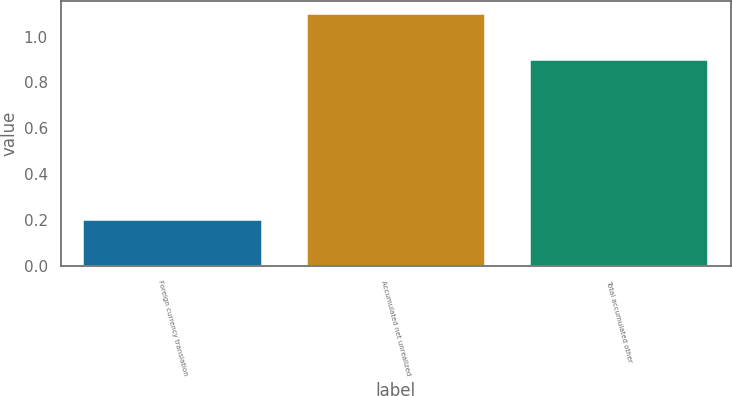<chart> <loc_0><loc_0><loc_500><loc_500><bar_chart><fcel>Foreign currency translation<fcel>Accumulated net unrealized<fcel>Total accumulated other<nl><fcel>0.2<fcel>1.1<fcel>0.9<nl></chart> 